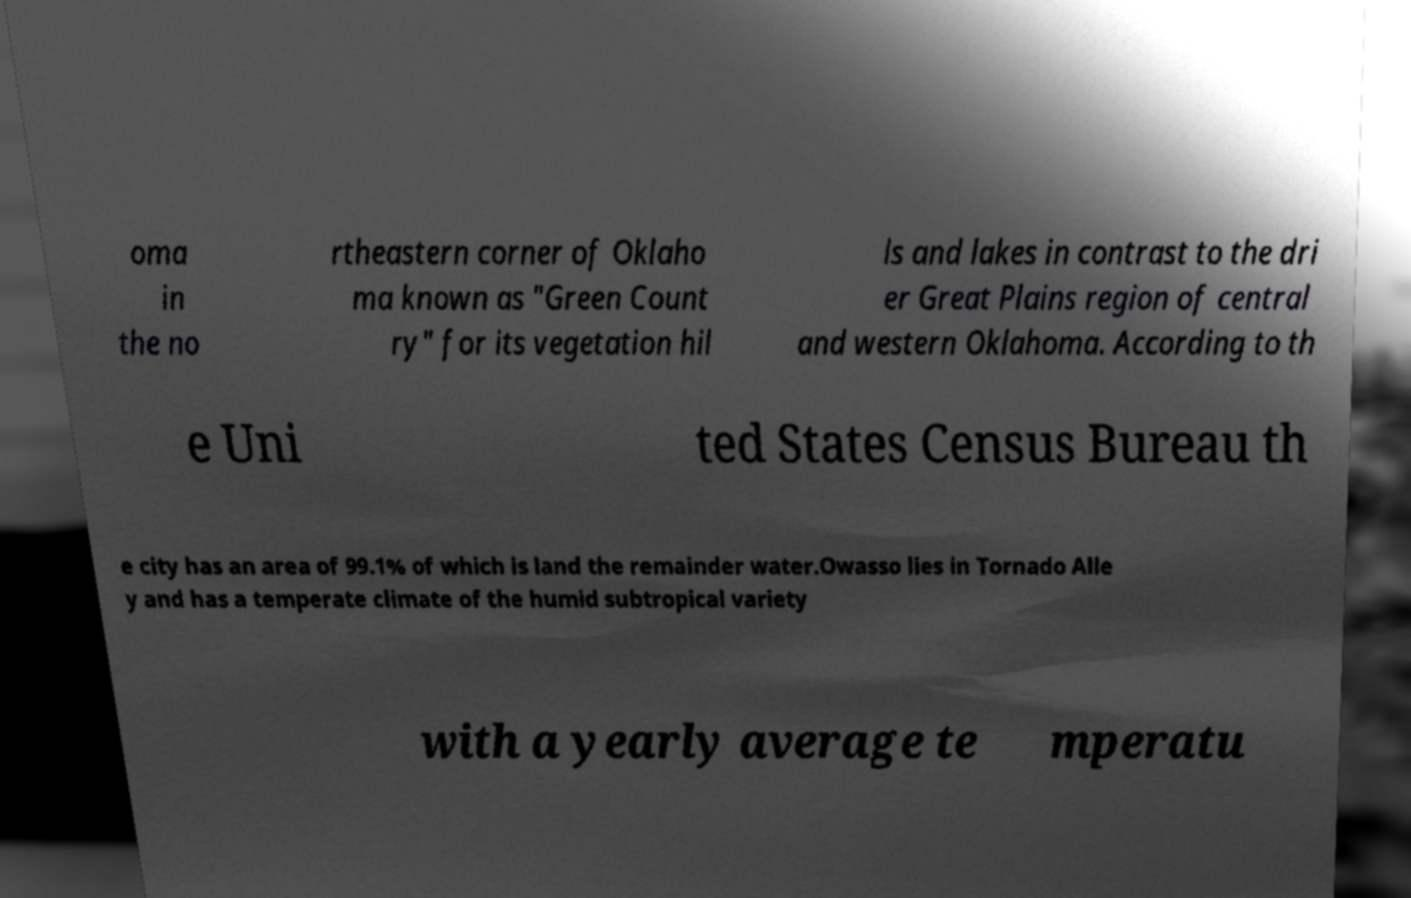I need the written content from this picture converted into text. Can you do that? oma in the no rtheastern corner of Oklaho ma known as "Green Count ry" for its vegetation hil ls and lakes in contrast to the dri er Great Plains region of central and western Oklahoma. According to th e Uni ted States Census Bureau th e city has an area of 99.1% of which is land the remainder water.Owasso lies in Tornado Alle y and has a temperate climate of the humid subtropical variety with a yearly average te mperatu 